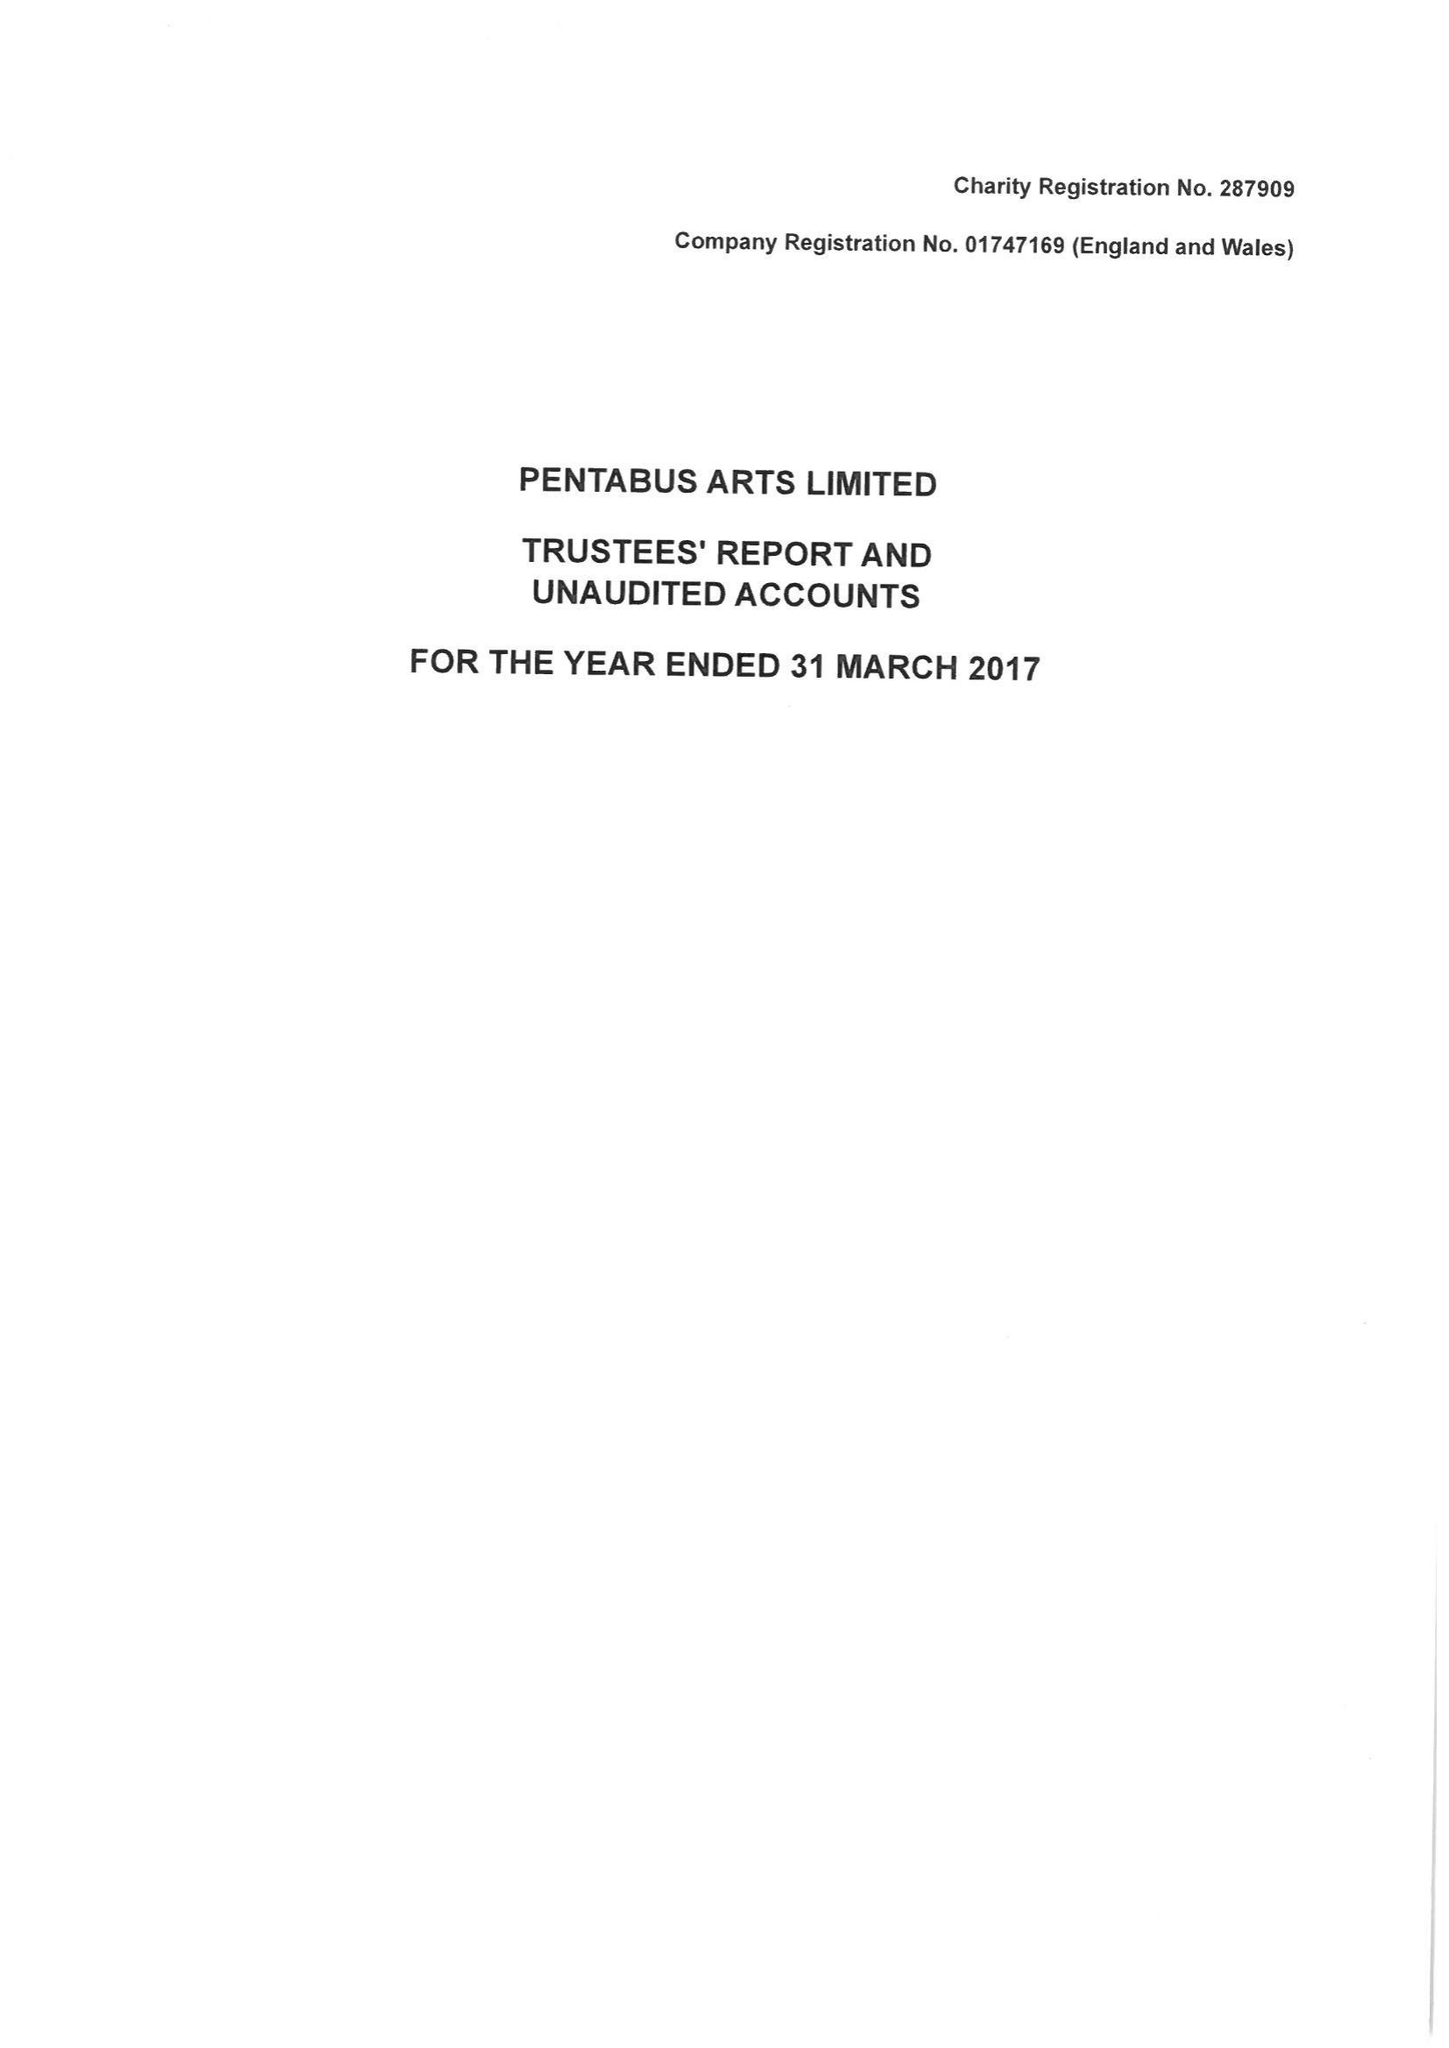What is the value for the spending_annually_in_british_pounds?
Answer the question using a single word or phrase. 334085.00 